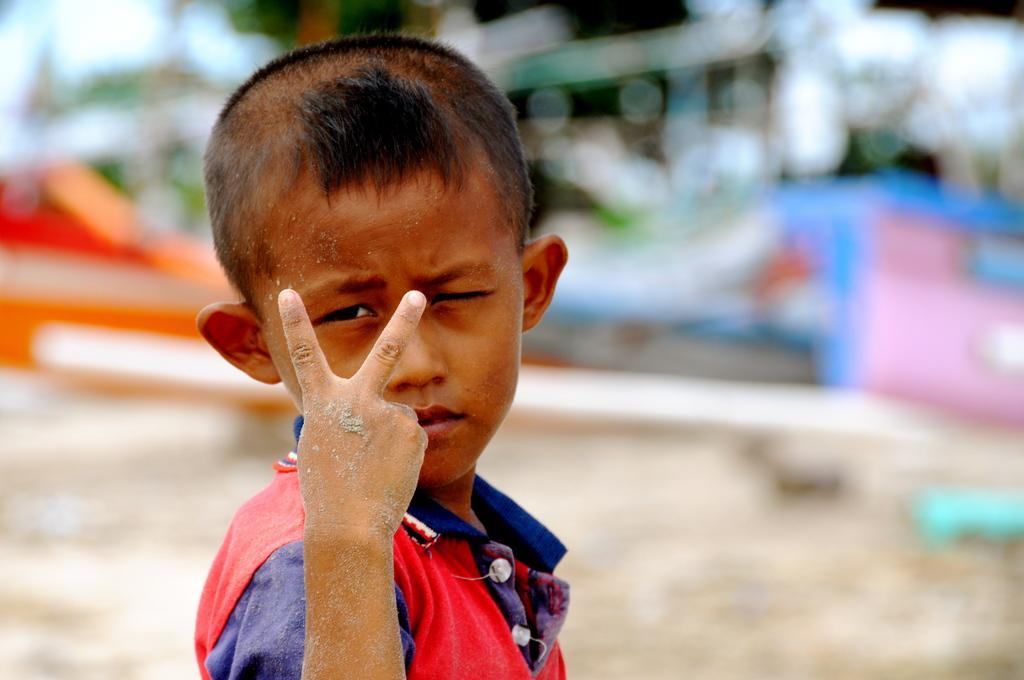Who is the main subject in the image? There is a boy in the image. What is the boy wearing? The boy is wearing clothes. What action is the boy performing in the image? The boy is showing two fingers. Can you describe the background of the image? The background of the image is blurred. What type of flame can be seen coming from the boy's fingers in the image? There is no flame present in the image; the boy is simply showing two fingers. 